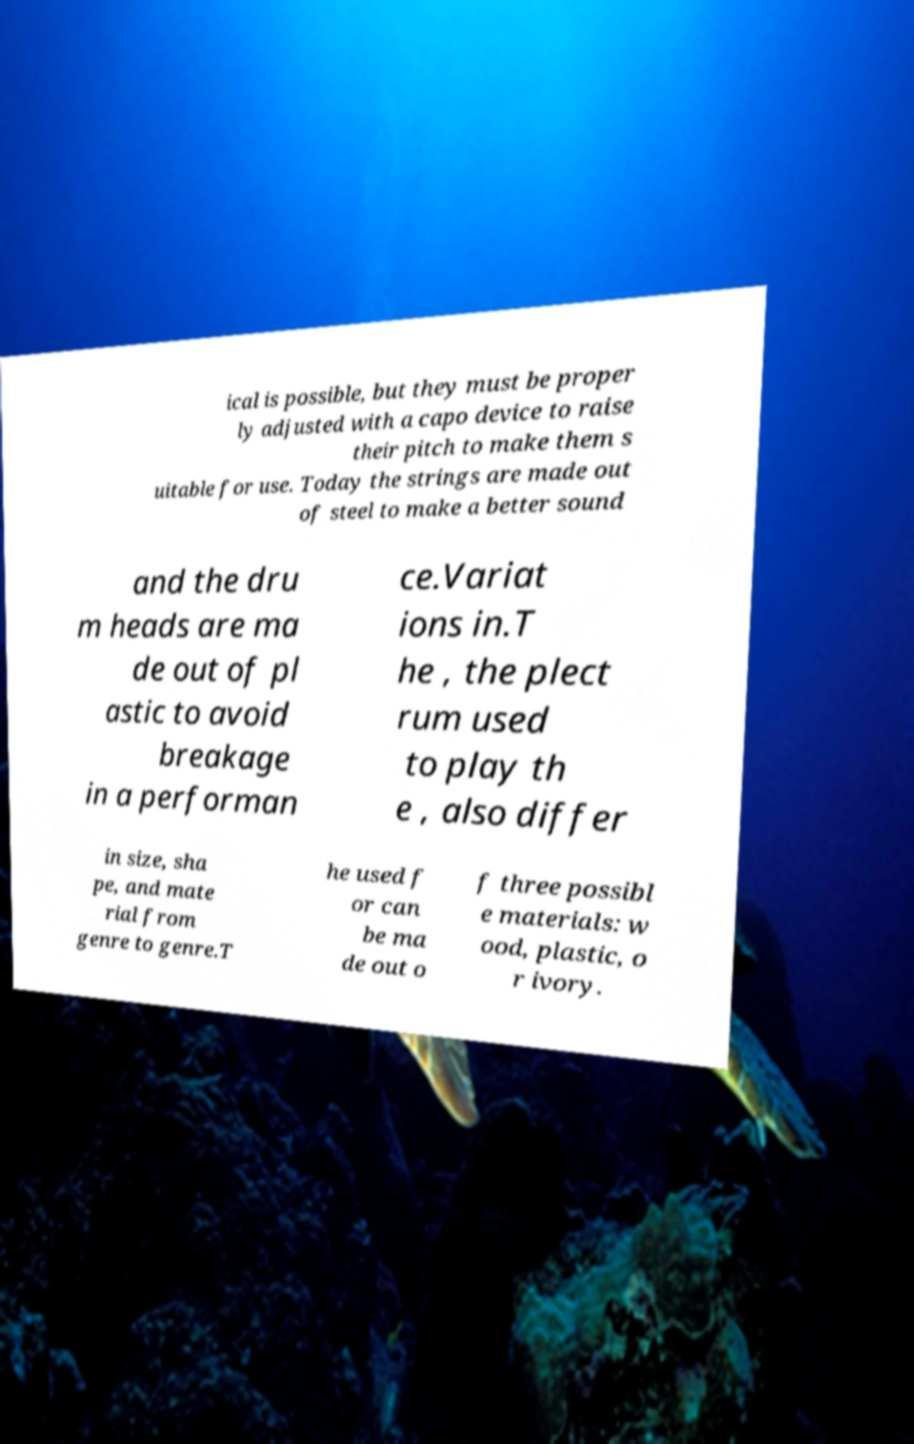For documentation purposes, I need the text within this image transcribed. Could you provide that? ical is possible, but they must be proper ly adjusted with a capo device to raise their pitch to make them s uitable for use. Today the strings are made out of steel to make a better sound and the dru m heads are ma de out of pl astic to avoid breakage in a performan ce.Variat ions in.T he , the plect rum used to play th e , also differ in size, sha pe, and mate rial from genre to genre.T he used f or can be ma de out o f three possibl e materials: w ood, plastic, o r ivory. 